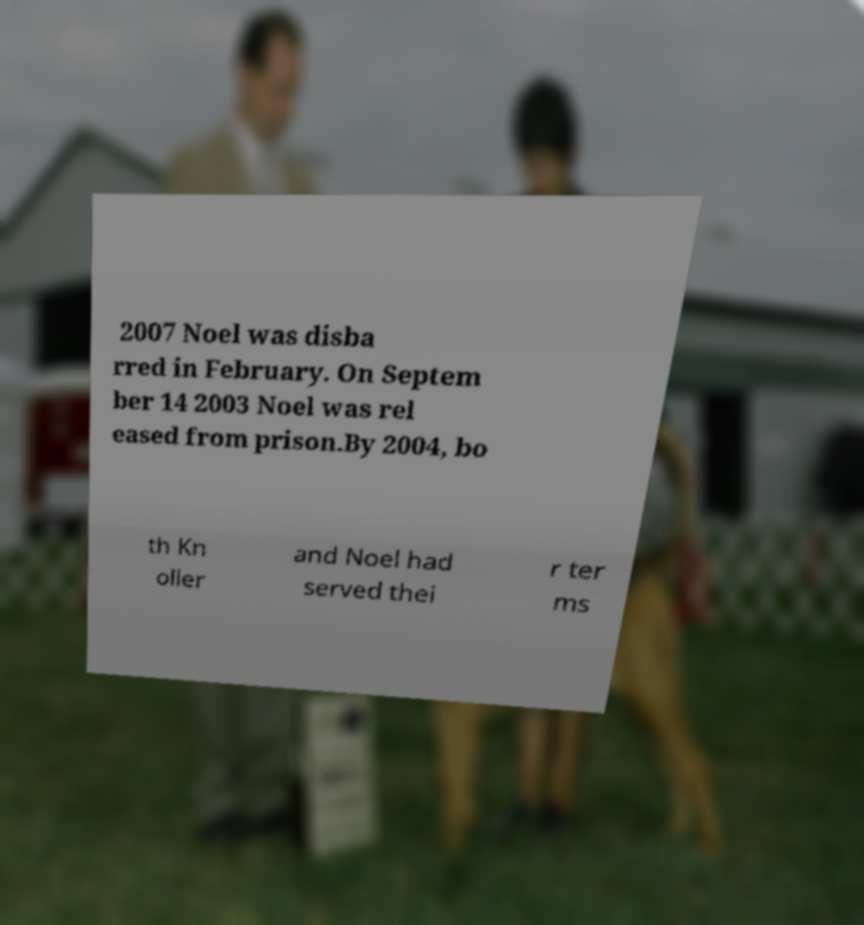For documentation purposes, I need the text within this image transcribed. Could you provide that? 2007 Noel was disba rred in February. On Septem ber 14 2003 Noel was rel eased from prison.By 2004, bo th Kn oller and Noel had served thei r ter ms 